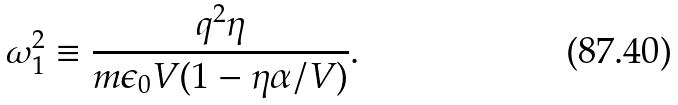Convert formula to latex. <formula><loc_0><loc_0><loc_500><loc_500>\omega _ { 1 } ^ { 2 } \equiv \frac { q ^ { 2 } \eta } { m \epsilon _ { 0 } V ( 1 - \eta \alpha / V ) } .</formula> 